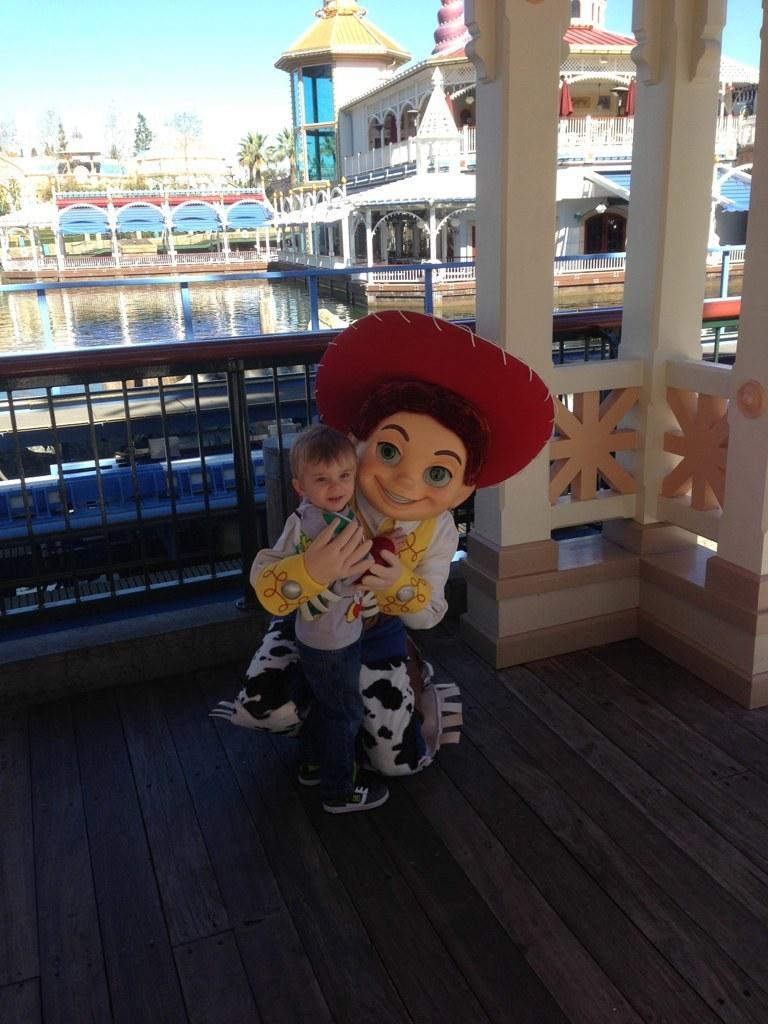In one or two sentences, can you explain what this image depicts? In this picture we can see a person in the fancy dress holding a boy. Behind the people there is a fence, water, trees, buildings, sky and other things. 